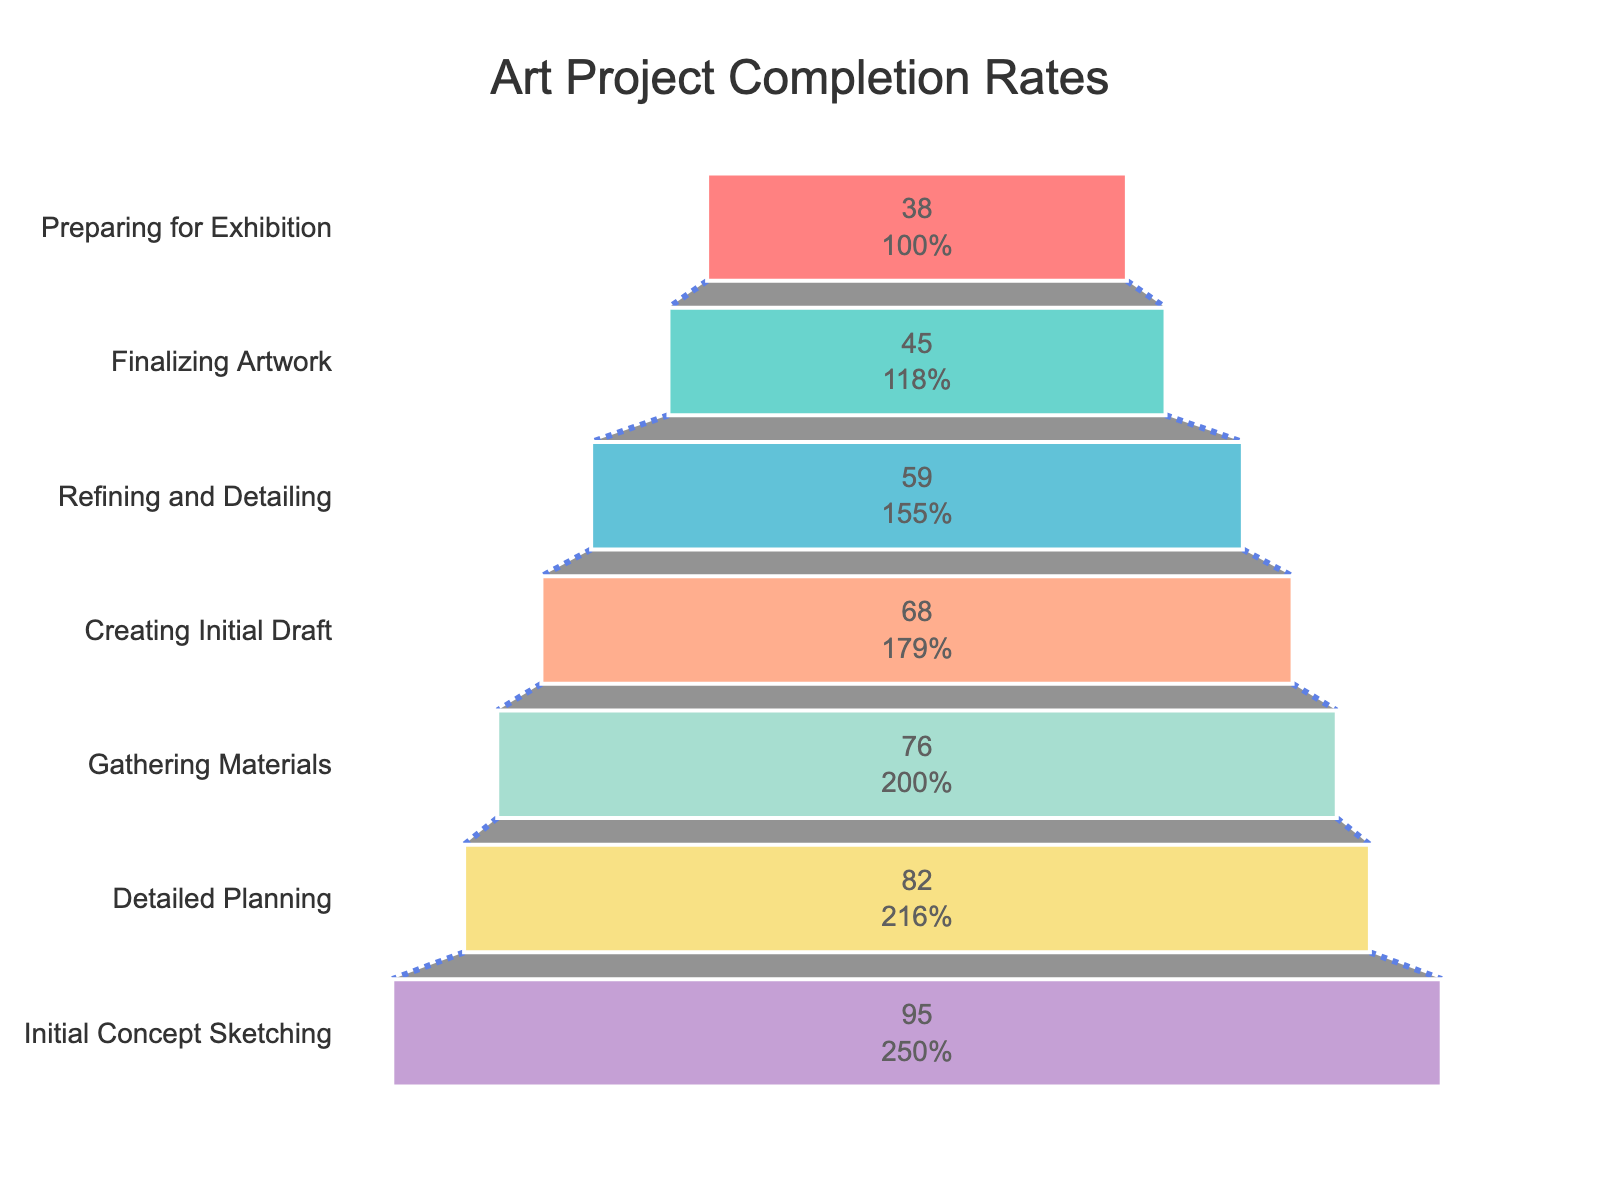What is the title of the funnel chart? The title of the chart is the text that appears prominently at the top. Here, it's the most descriptive label that explains what the chart represents.
Answer: Art Project Completion Rates How many stages are there in the art project according to the funnel chart? By counting the number of steps or segments in the funnel, each labeled with a different stage, we can determine the total number of stages.
Answer: 7 What is the completion rate for the Initial Concept Sketching stage? The completion rate is indicated within the segment representing each stage. The value inside the Initial Concept Sketching stage segment is the completion rate for that stage.
Answer: 95% Which stage has the lowest completion rate and what is that rate? By examining the completion rates of all stages, the segment with the smallest value represents the lowest completion rate.
Answer: Preparing for Exhibition, 38% What is the total drop in completion rates from Initial Concept Sketching to Preparing for Exhibition? Subtract the completion rate of Preparing for Exhibition from that of Initial Concept Sketching: 95% - 38% = 57%. This gives the total drop.
Answer: 57% Compared to the Detailed Planning stage, what is the percentage decrease in completion rate at the Gathering Materials stage? First find the difference in their completion rates: 82% - 76% = 6%. Then, divide this difference by the Detailed Planning rate and multiply by 100 to get the percentage decrease: (6 / 82) * 100 ≈ 7.32%.
Answer: ~7.32% What stage directly follows the Creating Initial Draft stage in the funnel chart? Look for the segment immediately below Creating Initial Draft. The label of this segment indicates the next stage.
Answer: Refining and Detailing During which stage does the largest drop in completion rate occur? By comparing the difference between consecutive stages' completion rates, the segment pair with the largest difference indicates the most significant drop. Refining and Detailing (59%) to Finalizing Artwork (45%) has the largest drop of 14%.
Answer: From Refining and Detailing to Finalizing Artwork How does the completion rate of Gathering Materials compare to Refining and Detailing? Compare the numerical values of their completion rates. Gathering Materials has a rate of 76% while Refining and Detailing has a rate of 59%.
Answer: Gathering Materials is higher by 17% Given the funnel chart's stages and completion rates, which stage sees a higher drop in percentage: Detailed Planning to Gathering Materials, or Refining and Detailing to Preparing for Exhibition? Calculate the drop for each pair. Detailed Planning (82%) to Gathering Materials (76%) is 6%. Refining and Detailing (59%) to Preparing for Exhibition (38%) is 21%. The drop from Refining and Detailing to Preparing for Exhibition is larger.
Answer: Refining and Detailing to Preparing for Exhibition 